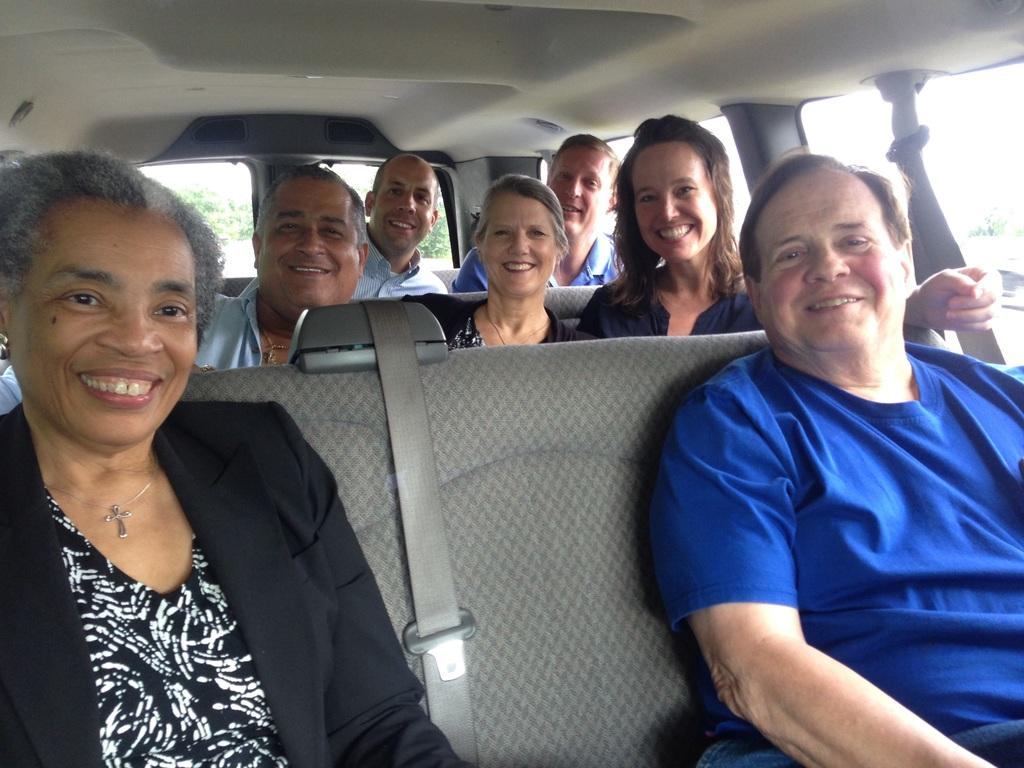What is happening in the image? There is a group of people in the image. Where are the people located? The people are seated in a vehicle. What is the mood or expression of the people in the image? The people are smiling. What type of foot can be seen in the image? There is no foot visible in the image; it only shows a group of people seated in a vehicle. 